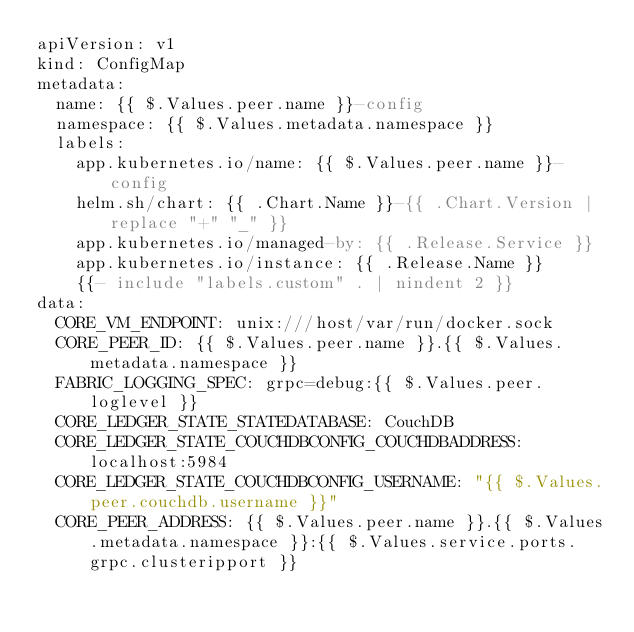<code> <loc_0><loc_0><loc_500><loc_500><_YAML_>apiVersion: v1
kind: ConfigMap
metadata:
  name: {{ $.Values.peer.name }}-config
  namespace: {{ $.Values.metadata.namespace }}
  labels:
    app.kubernetes.io/name: {{ $.Values.peer.name }}-config
    helm.sh/chart: {{ .Chart.Name }}-{{ .Chart.Version | replace "+" "_" }}
    app.kubernetes.io/managed-by: {{ .Release.Service }}
    app.kubernetes.io/instance: {{ .Release.Name }}
    {{- include "labels.custom" . | nindent 2 }}
data:
  CORE_VM_ENDPOINT: unix:///host/var/run/docker.sock
  CORE_PEER_ID: {{ $.Values.peer.name }}.{{ $.Values.metadata.namespace }}
  FABRIC_LOGGING_SPEC: grpc=debug:{{ $.Values.peer.loglevel }}
  CORE_LEDGER_STATE_STATEDATABASE: CouchDB
  CORE_LEDGER_STATE_COUCHDBCONFIG_COUCHDBADDRESS: localhost:5984
  CORE_LEDGER_STATE_COUCHDBCONFIG_USERNAME: "{{ $.Values.peer.couchdb.username }}"
  CORE_PEER_ADDRESS: {{ $.Values.peer.name }}.{{ $.Values.metadata.namespace }}:{{ $.Values.service.ports.grpc.clusteripport }}</code> 